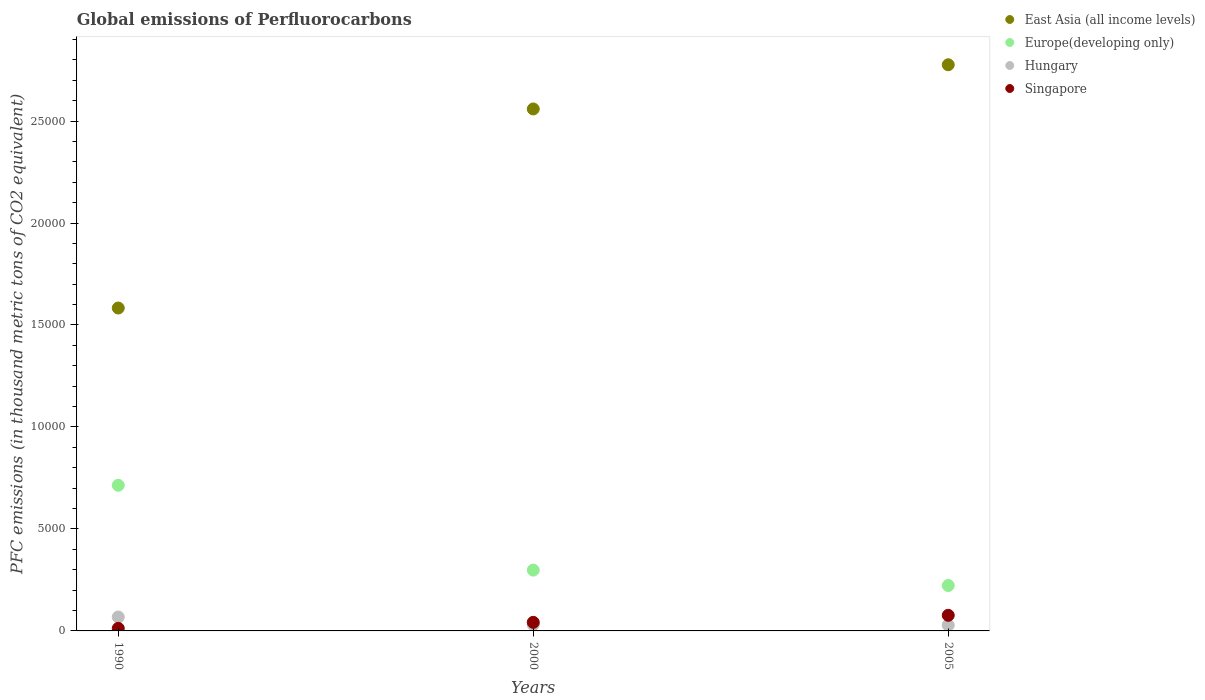What is the global emissions of Perfluorocarbons in Hungary in 1990?
Offer a very short reply. 683.3. Across all years, what is the maximum global emissions of Perfluorocarbons in East Asia (all income levels)?
Your answer should be compact. 2.78e+04. Across all years, what is the minimum global emissions of Perfluorocarbons in East Asia (all income levels)?
Make the answer very short. 1.58e+04. What is the total global emissions of Perfluorocarbons in Singapore in the graph?
Your answer should be compact. 1310.6. What is the difference between the global emissions of Perfluorocarbons in Europe(developing only) in 2000 and that in 2005?
Offer a very short reply. 755.18. What is the difference between the global emissions of Perfluorocarbons in East Asia (all income levels) in 2000 and the global emissions of Perfluorocarbons in Singapore in 1990?
Ensure brevity in your answer.  2.55e+04. What is the average global emissions of Perfluorocarbons in Hungary per year?
Provide a succinct answer. 425.17. In the year 2005, what is the difference between the global emissions of Perfluorocarbons in Europe(developing only) and global emissions of Perfluorocarbons in Singapore?
Make the answer very short. 1460.52. What is the ratio of the global emissions of Perfluorocarbons in Hungary in 2000 to that in 2005?
Your response must be concise. 1.09. Is the difference between the global emissions of Perfluorocarbons in Europe(developing only) in 2000 and 2005 greater than the difference between the global emissions of Perfluorocarbons in Singapore in 2000 and 2005?
Keep it short and to the point. Yes. What is the difference between the highest and the second highest global emissions of Perfluorocarbons in Singapore?
Your answer should be very brief. 344.6. What is the difference between the highest and the lowest global emissions of Perfluorocarbons in Europe(developing only)?
Offer a terse response. 4914.78. In how many years, is the global emissions of Perfluorocarbons in Singapore greater than the average global emissions of Perfluorocarbons in Singapore taken over all years?
Provide a succinct answer. 1. Is the sum of the global emissions of Perfluorocarbons in Singapore in 1990 and 2000 greater than the maximum global emissions of Perfluorocarbons in Hungary across all years?
Provide a short and direct response. No. Is it the case that in every year, the sum of the global emissions of Perfluorocarbons in Hungary and global emissions of Perfluorocarbons in East Asia (all income levels)  is greater than the sum of global emissions of Perfluorocarbons in Europe(developing only) and global emissions of Perfluorocarbons in Singapore?
Make the answer very short. Yes. Is it the case that in every year, the sum of the global emissions of Perfluorocarbons in East Asia (all income levels) and global emissions of Perfluorocarbons in Singapore  is greater than the global emissions of Perfluorocarbons in Hungary?
Ensure brevity in your answer.  Yes. Is the global emissions of Perfluorocarbons in Hungary strictly less than the global emissions of Perfluorocarbons in Europe(developing only) over the years?
Your answer should be very brief. Yes. How many years are there in the graph?
Offer a terse response. 3. Does the graph contain any zero values?
Your answer should be compact. No. How many legend labels are there?
Keep it short and to the point. 4. How are the legend labels stacked?
Keep it short and to the point. Vertical. What is the title of the graph?
Give a very brief answer. Global emissions of Perfluorocarbons. What is the label or title of the Y-axis?
Your response must be concise. PFC emissions (in thousand metric tons of CO2 equivalent). What is the PFC emissions (in thousand metric tons of CO2 equivalent) in East Asia (all income levels) in 1990?
Offer a terse response. 1.58e+04. What is the PFC emissions (in thousand metric tons of CO2 equivalent) of Europe(developing only) in 1990?
Provide a succinct answer. 7140.8. What is the PFC emissions (in thousand metric tons of CO2 equivalent) of Hungary in 1990?
Your answer should be very brief. 683.3. What is the PFC emissions (in thousand metric tons of CO2 equivalent) of Singapore in 1990?
Your response must be concise. 124.2. What is the PFC emissions (in thousand metric tons of CO2 equivalent) of East Asia (all income levels) in 2000?
Offer a terse response. 2.56e+04. What is the PFC emissions (in thousand metric tons of CO2 equivalent) in Europe(developing only) in 2000?
Provide a succinct answer. 2981.2. What is the PFC emissions (in thousand metric tons of CO2 equivalent) of Hungary in 2000?
Make the answer very short. 308.5. What is the PFC emissions (in thousand metric tons of CO2 equivalent) in Singapore in 2000?
Offer a very short reply. 420.9. What is the PFC emissions (in thousand metric tons of CO2 equivalent) of East Asia (all income levels) in 2005?
Offer a terse response. 2.78e+04. What is the PFC emissions (in thousand metric tons of CO2 equivalent) of Europe(developing only) in 2005?
Offer a terse response. 2226.02. What is the PFC emissions (in thousand metric tons of CO2 equivalent) of Hungary in 2005?
Offer a terse response. 283.7. What is the PFC emissions (in thousand metric tons of CO2 equivalent) of Singapore in 2005?
Your answer should be compact. 765.5. Across all years, what is the maximum PFC emissions (in thousand metric tons of CO2 equivalent) of East Asia (all income levels)?
Your answer should be compact. 2.78e+04. Across all years, what is the maximum PFC emissions (in thousand metric tons of CO2 equivalent) of Europe(developing only)?
Keep it short and to the point. 7140.8. Across all years, what is the maximum PFC emissions (in thousand metric tons of CO2 equivalent) in Hungary?
Offer a terse response. 683.3. Across all years, what is the maximum PFC emissions (in thousand metric tons of CO2 equivalent) of Singapore?
Offer a terse response. 765.5. Across all years, what is the minimum PFC emissions (in thousand metric tons of CO2 equivalent) in East Asia (all income levels)?
Provide a succinct answer. 1.58e+04. Across all years, what is the minimum PFC emissions (in thousand metric tons of CO2 equivalent) in Europe(developing only)?
Provide a short and direct response. 2226.02. Across all years, what is the minimum PFC emissions (in thousand metric tons of CO2 equivalent) of Hungary?
Provide a succinct answer. 283.7. Across all years, what is the minimum PFC emissions (in thousand metric tons of CO2 equivalent) in Singapore?
Offer a very short reply. 124.2. What is the total PFC emissions (in thousand metric tons of CO2 equivalent) in East Asia (all income levels) in the graph?
Ensure brevity in your answer.  6.92e+04. What is the total PFC emissions (in thousand metric tons of CO2 equivalent) of Europe(developing only) in the graph?
Offer a very short reply. 1.23e+04. What is the total PFC emissions (in thousand metric tons of CO2 equivalent) in Hungary in the graph?
Keep it short and to the point. 1275.5. What is the total PFC emissions (in thousand metric tons of CO2 equivalent) of Singapore in the graph?
Ensure brevity in your answer.  1310.6. What is the difference between the PFC emissions (in thousand metric tons of CO2 equivalent) in East Asia (all income levels) in 1990 and that in 2000?
Give a very brief answer. -9759.3. What is the difference between the PFC emissions (in thousand metric tons of CO2 equivalent) of Europe(developing only) in 1990 and that in 2000?
Offer a terse response. 4159.6. What is the difference between the PFC emissions (in thousand metric tons of CO2 equivalent) of Hungary in 1990 and that in 2000?
Your answer should be compact. 374.8. What is the difference between the PFC emissions (in thousand metric tons of CO2 equivalent) of Singapore in 1990 and that in 2000?
Your answer should be compact. -296.7. What is the difference between the PFC emissions (in thousand metric tons of CO2 equivalent) in East Asia (all income levels) in 1990 and that in 2005?
Keep it short and to the point. -1.19e+04. What is the difference between the PFC emissions (in thousand metric tons of CO2 equivalent) in Europe(developing only) in 1990 and that in 2005?
Provide a succinct answer. 4914.78. What is the difference between the PFC emissions (in thousand metric tons of CO2 equivalent) in Hungary in 1990 and that in 2005?
Keep it short and to the point. 399.6. What is the difference between the PFC emissions (in thousand metric tons of CO2 equivalent) in Singapore in 1990 and that in 2005?
Provide a succinct answer. -641.3. What is the difference between the PFC emissions (in thousand metric tons of CO2 equivalent) of East Asia (all income levels) in 2000 and that in 2005?
Ensure brevity in your answer.  -2167.69. What is the difference between the PFC emissions (in thousand metric tons of CO2 equivalent) of Europe(developing only) in 2000 and that in 2005?
Your response must be concise. 755.18. What is the difference between the PFC emissions (in thousand metric tons of CO2 equivalent) in Hungary in 2000 and that in 2005?
Provide a succinct answer. 24.8. What is the difference between the PFC emissions (in thousand metric tons of CO2 equivalent) of Singapore in 2000 and that in 2005?
Keep it short and to the point. -344.6. What is the difference between the PFC emissions (in thousand metric tons of CO2 equivalent) in East Asia (all income levels) in 1990 and the PFC emissions (in thousand metric tons of CO2 equivalent) in Europe(developing only) in 2000?
Provide a succinct answer. 1.29e+04. What is the difference between the PFC emissions (in thousand metric tons of CO2 equivalent) in East Asia (all income levels) in 1990 and the PFC emissions (in thousand metric tons of CO2 equivalent) in Hungary in 2000?
Ensure brevity in your answer.  1.55e+04. What is the difference between the PFC emissions (in thousand metric tons of CO2 equivalent) of East Asia (all income levels) in 1990 and the PFC emissions (in thousand metric tons of CO2 equivalent) of Singapore in 2000?
Offer a very short reply. 1.54e+04. What is the difference between the PFC emissions (in thousand metric tons of CO2 equivalent) of Europe(developing only) in 1990 and the PFC emissions (in thousand metric tons of CO2 equivalent) of Hungary in 2000?
Make the answer very short. 6832.3. What is the difference between the PFC emissions (in thousand metric tons of CO2 equivalent) of Europe(developing only) in 1990 and the PFC emissions (in thousand metric tons of CO2 equivalent) of Singapore in 2000?
Offer a very short reply. 6719.9. What is the difference between the PFC emissions (in thousand metric tons of CO2 equivalent) in Hungary in 1990 and the PFC emissions (in thousand metric tons of CO2 equivalent) in Singapore in 2000?
Your answer should be compact. 262.4. What is the difference between the PFC emissions (in thousand metric tons of CO2 equivalent) of East Asia (all income levels) in 1990 and the PFC emissions (in thousand metric tons of CO2 equivalent) of Europe(developing only) in 2005?
Your answer should be very brief. 1.36e+04. What is the difference between the PFC emissions (in thousand metric tons of CO2 equivalent) in East Asia (all income levels) in 1990 and the PFC emissions (in thousand metric tons of CO2 equivalent) in Hungary in 2005?
Ensure brevity in your answer.  1.55e+04. What is the difference between the PFC emissions (in thousand metric tons of CO2 equivalent) in East Asia (all income levels) in 1990 and the PFC emissions (in thousand metric tons of CO2 equivalent) in Singapore in 2005?
Provide a succinct answer. 1.51e+04. What is the difference between the PFC emissions (in thousand metric tons of CO2 equivalent) in Europe(developing only) in 1990 and the PFC emissions (in thousand metric tons of CO2 equivalent) in Hungary in 2005?
Keep it short and to the point. 6857.1. What is the difference between the PFC emissions (in thousand metric tons of CO2 equivalent) in Europe(developing only) in 1990 and the PFC emissions (in thousand metric tons of CO2 equivalent) in Singapore in 2005?
Keep it short and to the point. 6375.3. What is the difference between the PFC emissions (in thousand metric tons of CO2 equivalent) in Hungary in 1990 and the PFC emissions (in thousand metric tons of CO2 equivalent) in Singapore in 2005?
Your answer should be compact. -82.2. What is the difference between the PFC emissions (in thousand metric tons of CO2 equivalent) of East Asia (all income levels) in 2000 and the PFC emissions (in thousand metric tons of CO2 equivalent) of Europe(developing only) in 2005?
Offer a terse response. 2.34e+04. What is the difference between the PFC emissions (in thousand metric tons of CO2 equivalent) in East Asia (all income levels) in 2000 and the PFC emissions (in thousand metric tons of CO2 equivalent) in Hungary in 2005?
Offer a terse response. 2.53e+04. What is the difference between the PFC emissions (in thousand metric tons of CO2 equivalent) in East Asia (all income levels) in 2000 and the PFC emissions (in thousand metric tons of CO2 equivalent) in Singapore in 2005?
Keep it short and to the point. 2.48e+04. What is the difference between the PFC emissions (in thousand metric tons of CO2 equivalent) in Europe(developing only) in 2000 and the PFC emissions (in thousand metric tons of CO2 equivalent) in Hungary in 2005?
Your answer should be compact. 2697.5. What is the difference between the PFC emissions (in thousand metric tons of CO2 equivalent) of Europe(developing only) in 2000 and the PFC emissions (in thousand metric tons of CO2 equivalent) of Singapore in 2005?
Keep it short and to the point. 2215.7. What is the difference between the PFC emissions (in thousand metric tons of CO2 equivalent) of Hungary in 2000 and the PFC emissions (in thousand metric tons of CO2 equivalent) of Singapore in 2005?
Ensure brevity in your answer.  -457. What is the average PFC emissions (in thousand metric tons of CO2 equivalent) in East Asia (all income levels) per year?
Give a very brief answer. 2.31e+04. What is the average PFC emissions (in thousand metric tons of CO2 equivalent) of Europe(developing only) per year?
Make the answer very short. 4116.01. What is the average PFC emissions (in thousand metric tons of CO2 equivalent) of Hungary per year?
Keep it short and to the point. 425.17. What is the average PFC emissions (in thousand metric tons of CO2 equivalent) of Singapore per year?
Provide a succinct answer. 436.87. In the year 1990, what is the difference between the PFC emissions (in thousand metric tons of CO2 equivalent) in East Asia (all income levels) and PFC emissions (in thousand metric tons of CO2 equivalent) in Europe(developing only)?
Provide a succinct answer. 8690.9. In the year 1990, what is the difference between the PFC emissions (in thousand metric tons of CO2 equivalent) of East Asia (all income levels) and PFC emissions (in thousand metric tons of CO2 equivalent) of Hungary?
Your answer should be very brief. 1.51e+04. In the year 1990, what is the difference between the PFC emissions (in thousand metric tons of CO2 equivalent) in East Asia (all income levels) and PFC emissions (in thousand metric tons of CO2 equivalent) in Singapore?
Offer a terse response. 1.57e+04. In the year 1990, what is the difference between the PFC emissions (in thousand metric tons of CO2 equivalent) of Europe(developing only) and PFC emissions (in thousand metric tons of CO2 equivalent) of Hungary?
Offer a very short reply. 6457.5. In the year 1990, what is the difference between the PFC emissions (in thousand metric tons of CO2 equivalent) in Europe(developing only) and PFC emissions (in thousand metric tons of CO2 equivalent) in Singapore?
Provide a short and direct response. 7016.6. In the year 1990, what is the difference between the PFC emissions (in thousand metric tons of CO2 equivalent) in Hungary and PFC emissions (in thousand metric tons of CO2 equivalent) in Singapore?
Ensure brevity in your answer.  559.1. In the year 2000, what is the difference between the PFC emissions (in thousand metric tons of CO2 equivalent) of East Asia (all income levels) and PFC emissions (in thousand metric tons of CO2 equivalent) of Europe(developing only)?
Provide a succinct answer. 2.26e+04. In the year 2000, what is the difference between the PFC emissions (in thousand metric tons of CO2 equivalent) of East Asia (all income levels) and PFC emissions (in thousand metric tons of CO2 equivalent) of Hungary?
Your answer should be very brief. 2.53e+04. In the year 2000, what is the difference between the PFC emissions (in thousand metric tons of CO2 equivalent) in East Asia (all income levels) and PFC emissions (in thousand metric tons of CO2 equivalent) in Singapore?
Your response must be concise. 2.52e+04. In the year 2000, what is the difference between the PFC emissions (in thousand metric tons of CO2 equivalent) of Europe(developing only) and PFC emissions (in thousand metric tons of CO2 equivalent) of Hungary?
Keep it short and to the point. 2672.7. In the year 2000, what is the difference between the PFC emissions (in thousand metric tons of CO2 equivalent) of Europe(developing only) and PFC emissions (in thousand metric tons of CO2 equivalent) of Singapore?
Your answer should be compact. 2560.3. In the year 2000, what is the difference between the PFC emissions (in thousand metric tons of CO2 equivalent) in Hungary and PFC emissions (in thousand metric tons of CO2 equivalent) in Singapore?
Offer a terse response. -112.4. In the year 2005, what is the difference between the PFC emissions (in thousand metric tons of CO2 equivalent) in East Asia (all income levels) and PFC emissions (in thousand metric tons of CO2 equivalent) in Europe(developing only)?
Provide a succinct answer. 2.55e+04. In the year 2005, what is the difference between the PFC emissions (in thousand metric tons of CO2 equivalent) of East Asia (all income levels) and PFC emissions (in thousand metric tons of CO2 equivalent) of Hungary?
Keep it short and to the point. 2.75e+04. In the year 2005, what is the difference between the PFC emissions (in thousand metric tons of CO2 equivalent) of East Asia (all income levels) and PFC emissions (in thousand metric tons of CO2 equivalent) of Singapore?
Make the answer very short. 2.70e+04. In the year 2005, what is the difference between the PFC emissions (in thousand metric tons of CO2 equivalent) in Europe(developing only) and PFC emissions (in thousand metric tons of CO2 equivalent) in Hungary?
Your answer should be very brief. 1942.32. In the year 2005, what is the difference between the PFC emissions (in thousand metric tons of CO2 equivalent) of Europe(developing only) and PFC emissions (in thousand metric tons of CO2 equivalent) of Singapore?
Offer a terse response. 1460.52. In the year 2005, what is the difference between the PFC emissions (in thousand metric tons of CO2 equivalent) in Hungary and PFC emissions (in thousand metric tons of CO2 equivalent) in Singapore?
Ensure brevity in your answer.  -481.8. What is the ratio of the PFC emissions (in thousand metric tons of CO2 equivalent) of East Asia (all income levels) in 1990 to that in 2000?
Ensure brevity in your answer.  0.62. What is the ratio of the PFC emissions (in thousand metric tons of CO2 equivalent) in Europe(developing only) in 1990 to that in 2000?
Your answer should be very brief. 2.4. What is the ratio of the PFC emissions (in thousand metric tons of CO2 equivalent) in Hungary in 1990 to that in 2000?
Make the answer very short. 2.21. What is the ratio of the PFC emissions (in thousand metric tons of CO2 equivalent) in Singapore in 1990 to that in 2000?
Provide a short and direct response. 0.3. What is the ratio of the PFC emissions (in thousand metric tons of CO2 equivalent) in East Asia (all income levels) in 1990 to that in 2005?
Provide a succinct answer. 0.57. What is the ratio of the PFC emissions (in thousand metric tons of CO2 equivalent) of Europe(developing only) in 1990 to that in 2005?
Make the answer very short. 3.21. What is the ratio of the PFC emissions (in thousand metric tons of CO2 equivalent) of Hungary in 1990 to that in 2005?
Offer a terse response. 2.41. What is the ratio of the PFC emissions (in thousand metric tons of CO2 equivalent) of Singapore in 1990 to that in 2005?
Make the answer very short. 0.16. What is the ratio of the PFC emissions (in thousand metric tons of CO2 equivalent) in East Asia (all income levels) in 2000 to that in 2005?
Make the answer very short. 0.92. What is the ratio of the PFC emissions (in thousand metric tons of CO2 equivalent) of Europe(developing only) in 2000 to that in 2005?
Offer a terse response. 1.34. What is the ratio of the PFC emissions (in thousand metric tons of CO2 equivalent) in Hungary in 2000 to that in 2005?
Offer a very short reply. 1.09. What is the ratio of the PFC emissions (in thousand metric tons of CO2 equivalent) of Singapore in 2000 to that in 2005?
Offer a very short reply. 0.55. What is the difference between the highest and the second highest PFC emissions (in thousand metric tons of CO2 equivalent) of East Asia (all income levels)?
Provide a succinct answer. 2167.69. What is the difference between the highest and the second highest PFC emissions (in thousand metric tons of CO2 equivalent) of Europe(developing only)?
Your response must be concise. 4159.6. What is the difference between the highest and the second highest PFC emissions (in thousand metric tons of CO2 equivalent) of Hungary?
Your answer should be compact. 374.8. What is the difference between the highest and the second highest PFC emissions (in thousand metric tons of CO2 equivalent) of Singapore?
Your answer should be very brief. 344.6. What is the difference between the highest and the lowest PFC emissions (in thousand metric tons of CO2 equivalent) of East Asia (all income levels)?
Provide a short and direct response. 1.19e+04. What is the difference between the highest and the lowest PFC emissions (in thousand metric tons of CO2 equivalent) of Europe(developing only)?
Your answer should be very brief. 4914.78. What is the difference between the highest and the lowest PFC emissions (in thousand metric tons of CO2 equivalent) in Hungary?
Give a very brief answer. 399.6. What is the difference between the highest and the lowest PFC emissions (in thousand metric tons of CO2 equivalent) in Singapore?
Give a very brief answer. 641.3. 